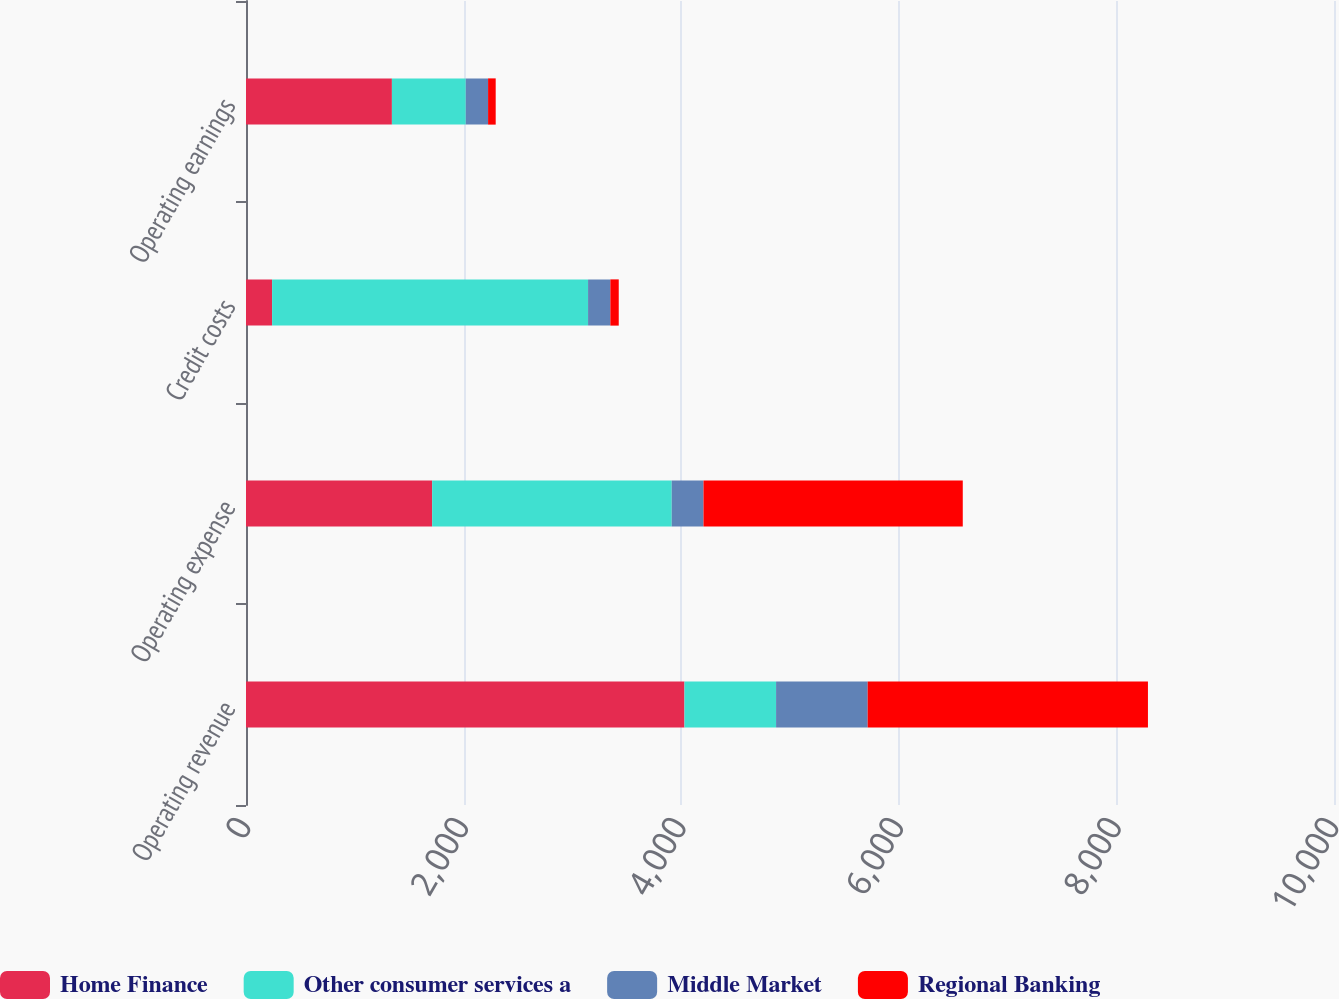Convert chart. <chart><loc_0><loc_0><loc_500><loc_500><stacked_bar_chart><ecel><fcel>Operating revenue<fcel>Operating expense<fcel>Credit costs<fcel>Operating earnings<nl><fcel>Home Finance<fcel>4030<fcel>1711<fcel>240<fcel>1341<nl><fcel>Other consumer services a<fcel>842<fcel>2202<fcel>2904<fcel>679<nl><fcel>Middle Market<fcel>842<fcel>292<fcel>205<fcel>205<nl><fcel>Regional Banking<fcel>2576<fcel>2383<fcel>77<fcel>70<nl></chart> 